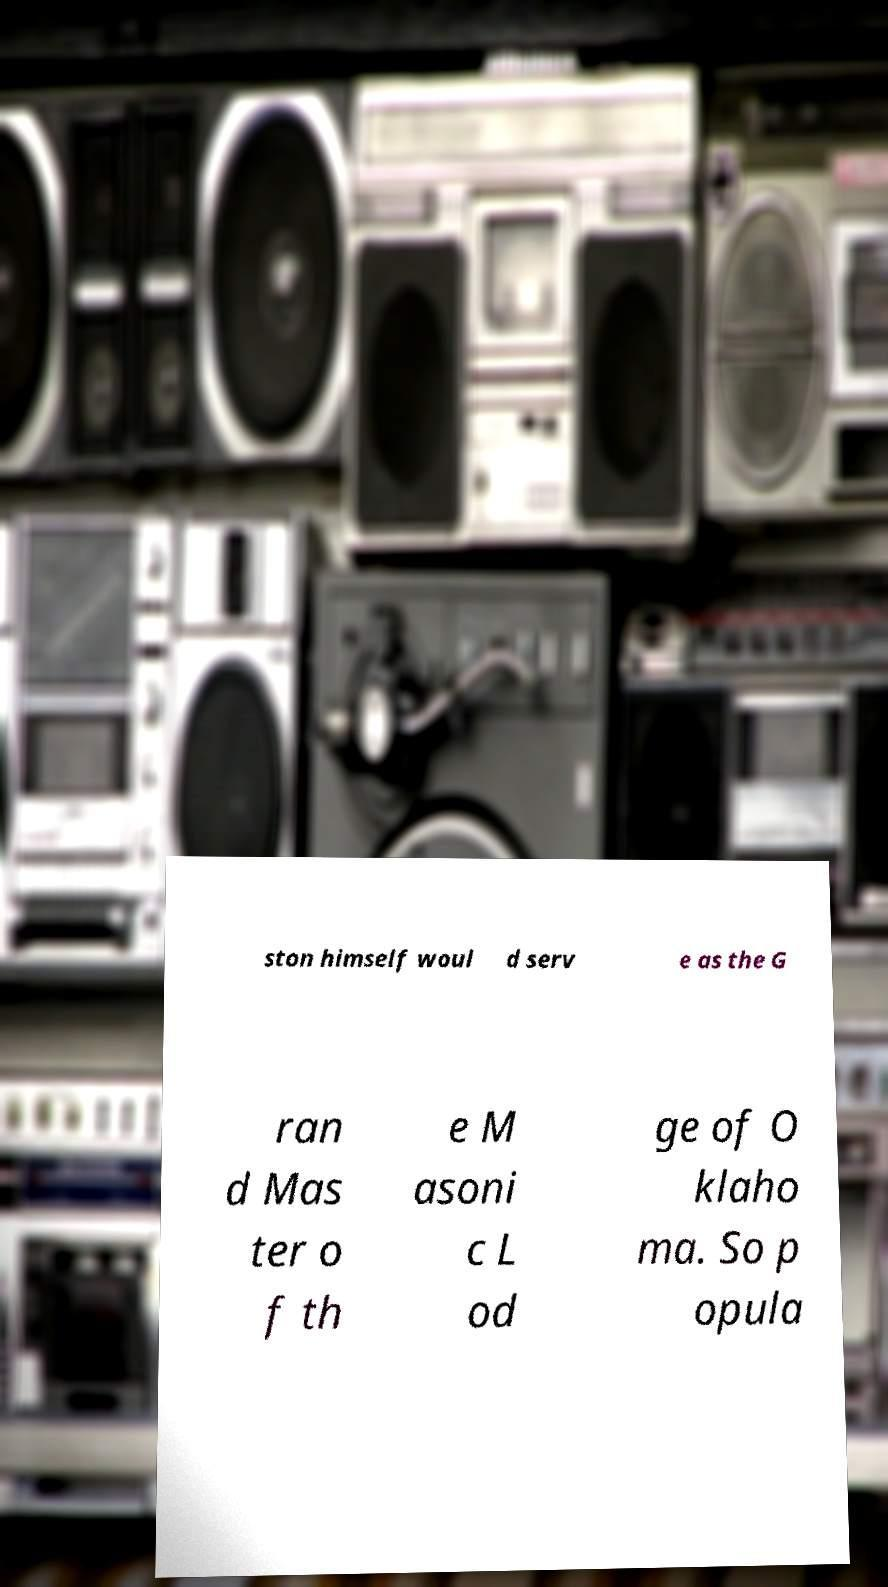Could you extract and type out the text from this image? ston himself woul d serv e as the G ran d Mas ter o f th e M asoni c L od ge of O klaho ma. So p opula 